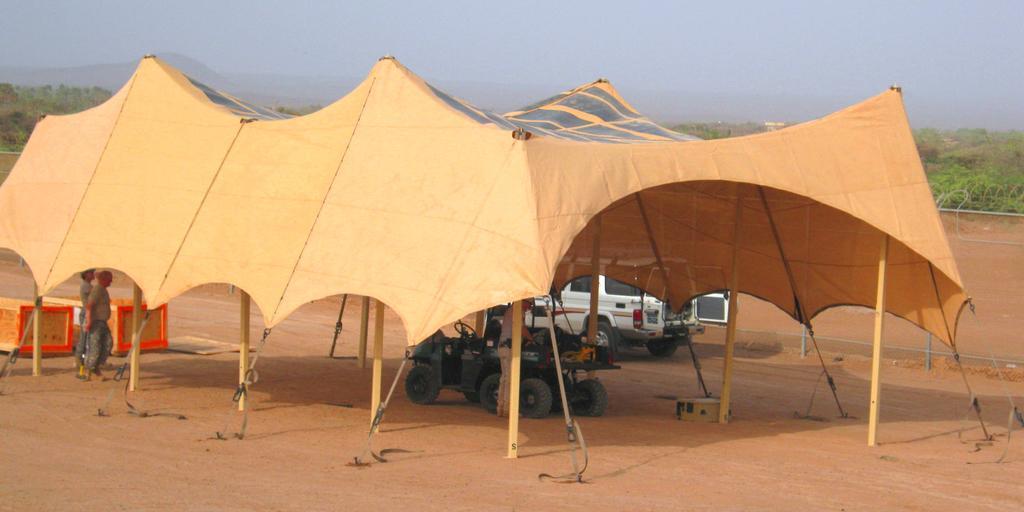Please provide a concise description of this image. In this image there is tent under the tent there is vehicle and two men are standing, outside the tent there are two boxes and a car, in the background there is fencing and outside the fencing there are trees and cloudy sky. 